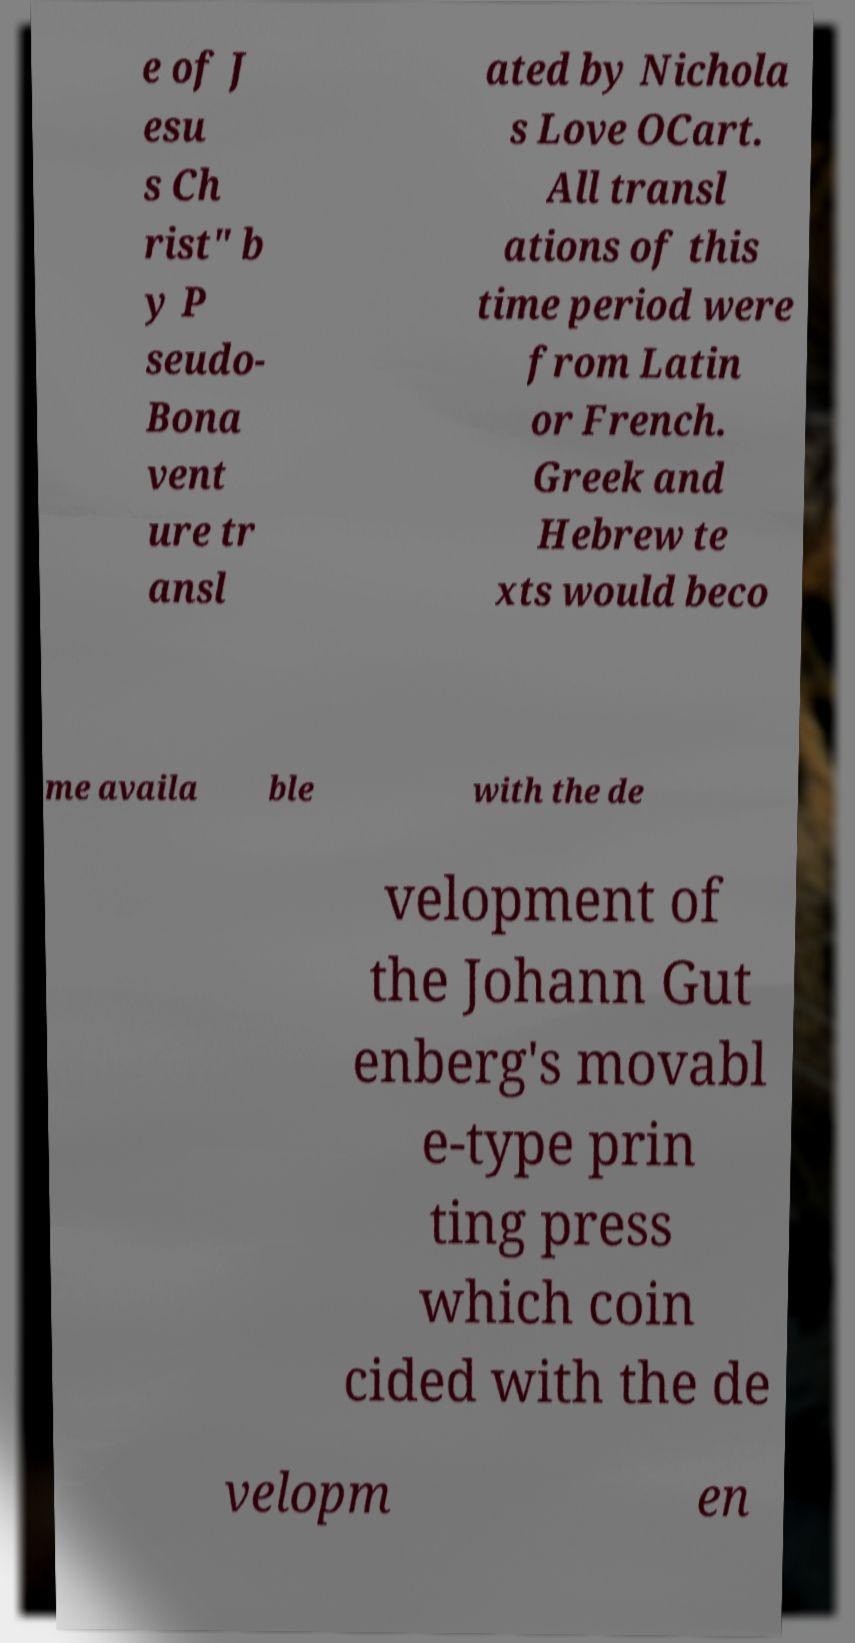Can you accurately transcribe the text from the provided image for me? e of J esu s Ch rist" b y P seudo- Bona vent ure tr ansl ated by Nichola s Love OCart. All transl ations of this time period were from Latin or French. Greek and Hebrew te xts would beco me availa ble with the de velopment of the Johann Gut enberg's movabl e-type prin ting press which coin cided with the de velopm en 